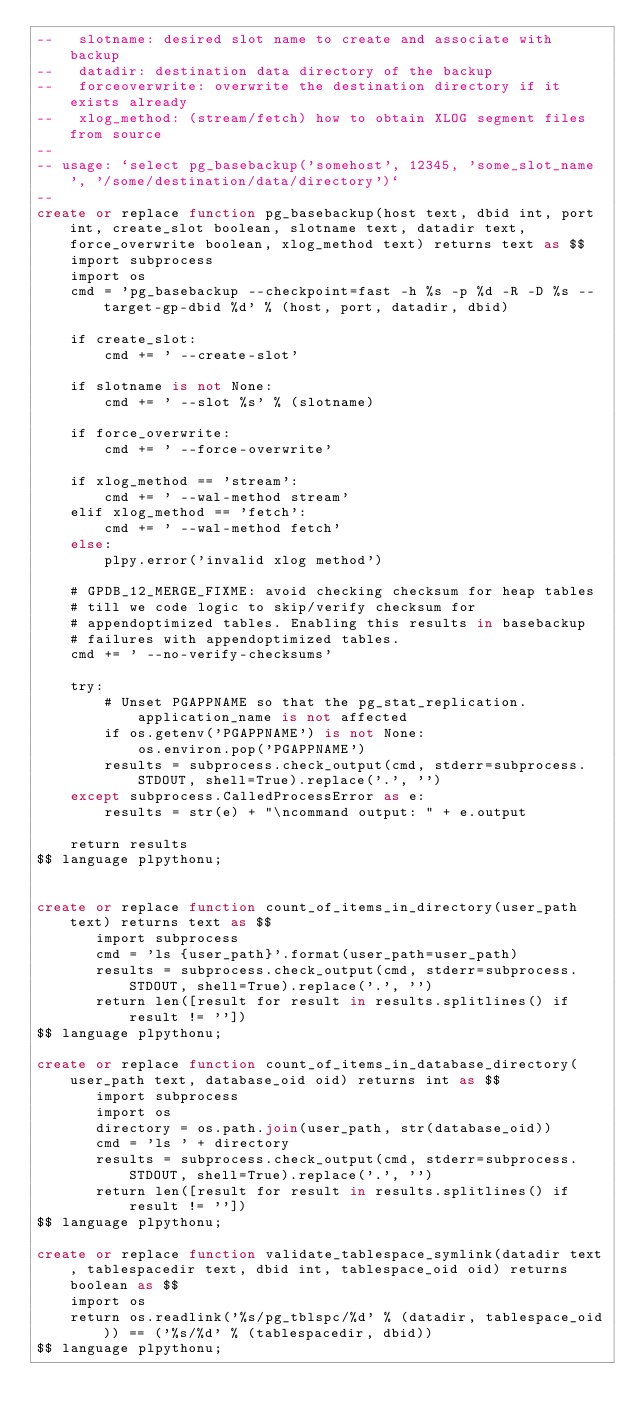<code> <loc_0><loc_0><loc_500><loc_500><_SQL_>--   slotname: desired slot name to create and associate with backup
--   datadir: destination data directory of the backup
--   forceoverwrite: overwrite the destination directory if it exists already
--   xlog_method: (stream/fetch) how to obtain XLOG segment files from source
--
-- usage: `select pg_basebackup('somehost', 12345, 'some_slot_name', '/some/destination/data/directory')`
--
create or replace function pg_basebackup(host text, dbid int, port int, create_slot boolean, slotname text, datadir text, force_overwrite boolean, xlog_method text) returns text as $$
    import subprocess
    import os
    cmd = 'pg_basebackup --checkpoint=fast -h %s -p %d -R -D %s --target-gp-dbid %d' % (host, port, datadir, dbid)

    if create_slot:
        cmd += ' --create-slot'

    if slotname is not None:
        cmd += ' --slot %s' % (slotname)

    if force_overwrite:
        cmd += ' --force-overwrite'

    if xlog_method == 'stream':
        cmd += ' --wal-method stream'
    elif xlog_method == 'fetch':
        cmd += ' --wal-method fetch'
    else:
        plpy.error('invalid xlog method')

    # GPDB_12_MERGE_FIXME: avoid checking checksum for heap tables
    # till we code logic to skip/verify checksum for
    # appendoptimized tables. Enabling this results in basebackup
    # failures with appendoptimized tables.
    cmd += ' --no-verify-checksums'

    try:
        # Unset PGAPPNAME so that the pg_stat_replication.application_name is not affected
        if os.getenv('PGAPPNAME') is not None:
            os.environ.pop('PGAPPNAME')
        results = subprocess.check_output(cmd, stderr=subprocess.STDOUT, shell=True).replace('.', '')
    except subprocess.CalledProcessError as e:
        results = str(e) + "\ncommand output: " + e.output

    return results
$$ language plpythonu;


create or replace function count_of_items_in_directory(user_path text) returns text as $$
       import subprocess
       cmd = 'ls {user_path}'.format(user_path=user_path)
       results = subprocess.check_output(cmd, stderr=subprocess.STDOUT, shell=True).replace('.', '')
       return len([result for result in results.splitlines() if result != ''])
$$ language plpythonu;

create or replace function count_of_items_in_database_directory(user_path text, database_oid oid) returns int as $$
       import subprocess
       import os
       directory = os.path.join(user_path, str(database_oid))
       cmd = 'ls ' + directory
       results = subprocess.check_output(cmd, stderr=subprocess.STDOUT, shell=True).replace('.', '')
       return len([result for result in results.splitlines() if result != ''])
$$ language plpythonu;

create or replace function validate_tablespace_symlink(datadir text, tablespacedir text, dbid int, tablespace_oid oid) returns boolean as $$
    import os
    return os.readlink('%s/pg_tblspc/%d' % (datadir, tablespace_oid)) == ('%s/%d' % (tablespacedir, dbid))
$$ language plpythonu;
</code> 